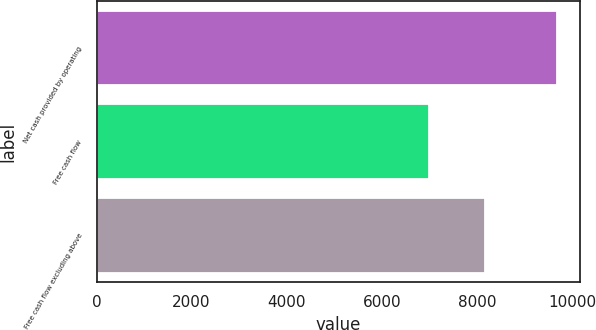Convert chart to OTSL. <chart><loc_0><loc_0><loc_500><loc_500><bar_chart><fcel>Net cash provided by operating<fcel>Free cash flow<fcel>Free cash flow excluding above<nl><fcel>9688<fcel>7002<fcel>8162<nl></chart> 